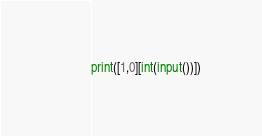Convert code to text. <code><loc_0><loc_0><loc_500><loc_500><_Python_>print([1,0][int(input())])</code> 